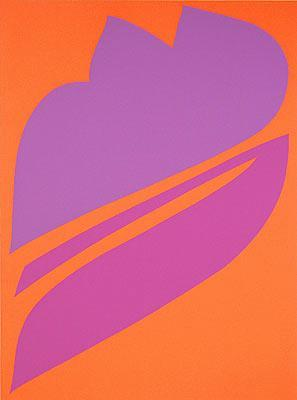What is this photo about'?
 This image is a captivating piece of abstract art. The canvas is dominated by a bright orange background, which serves as a stark contrast to the central figure. This figure, a large purple shape, draws the eye with its unique form. It is composed of three intersecting curved lines, creating an intriguing leaf-like shape. The minimalistic art style of this piece further emphasizes the bold colors and shapes, making it a striking example of the abstract genre. The simplicity of the design, combined with the vibrant colors, gives the artwork a dynamic and modern feel. 